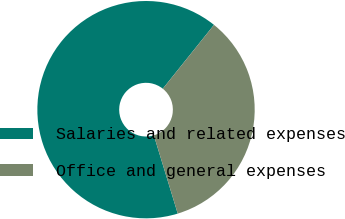Convert chart. <chart><loc_0><loc_0><loc_500><loc_500><pie_chart><fcel>Salaries and related expenses<fcel>Office and general expenses<nl><fcel>65.47%<fcel>34.53%<nl></chart> 